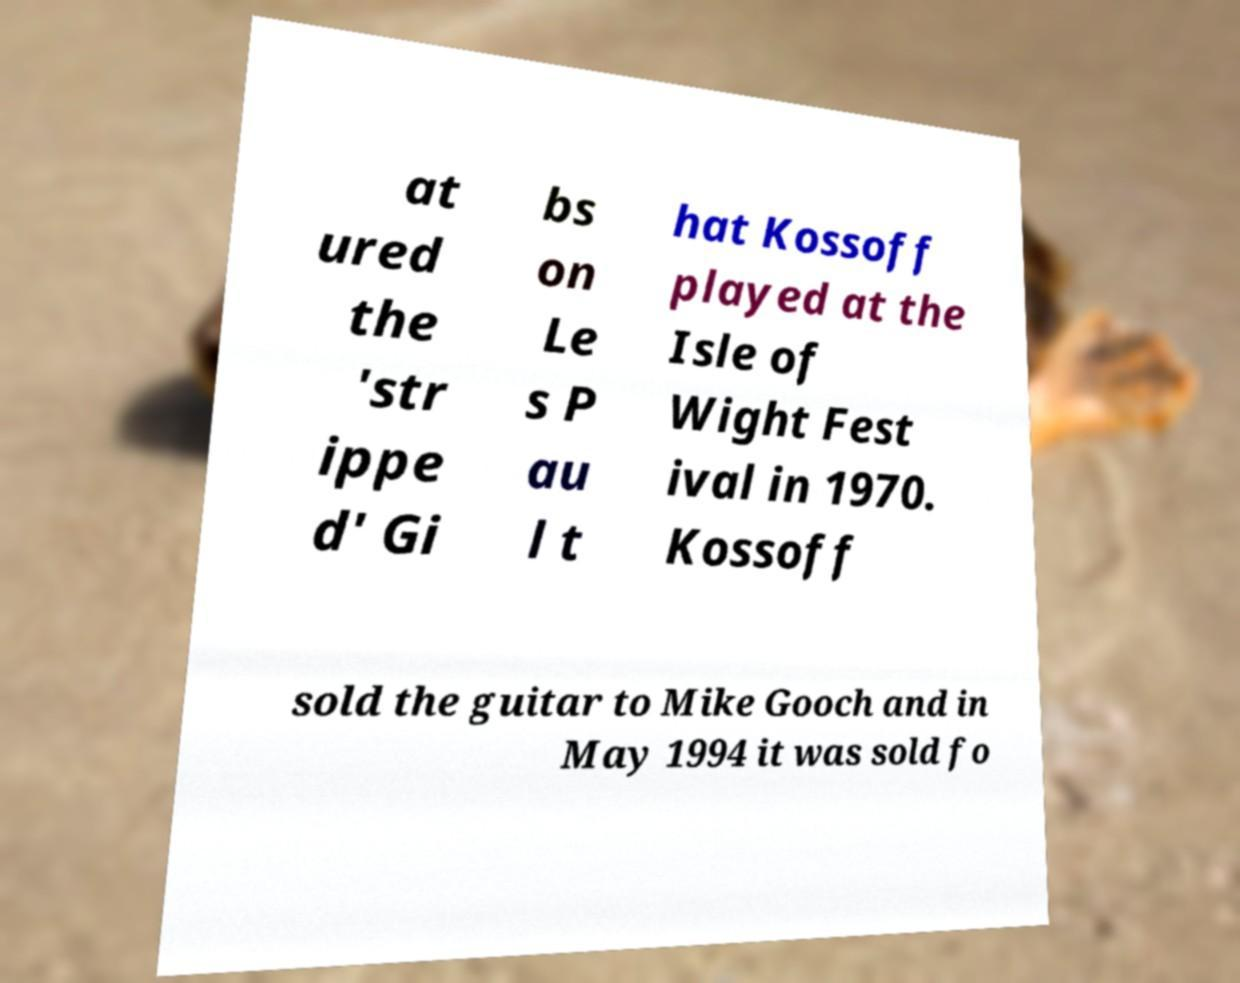Could you assist in decoding the text presented in this image and type it out clearly? at ured the 'str ippe d' Gi bs on Le s P au l t hat Kossoff played at the Isle of Wight Fest ival in 1970. Kossoff sold the guitar to Mike Gooch and in May 1994 it was sold fo 